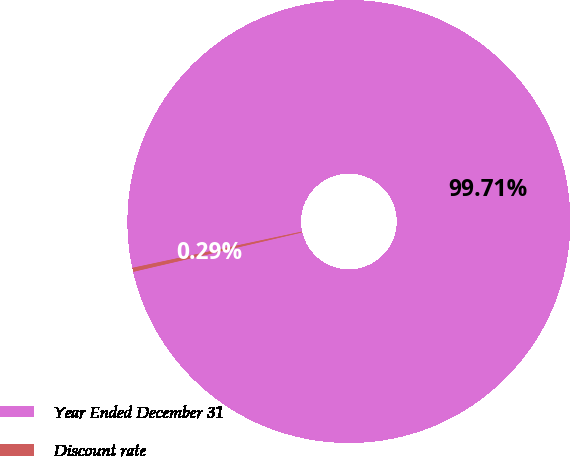Convert chart. <chart><loc_0><loc_0><loc_500><loc_500><pie_chart><fcel>Year Ended December 31<fcel>Discount rate<nl><fcel>99.71%<fcel>0.29%<nl></chart> 